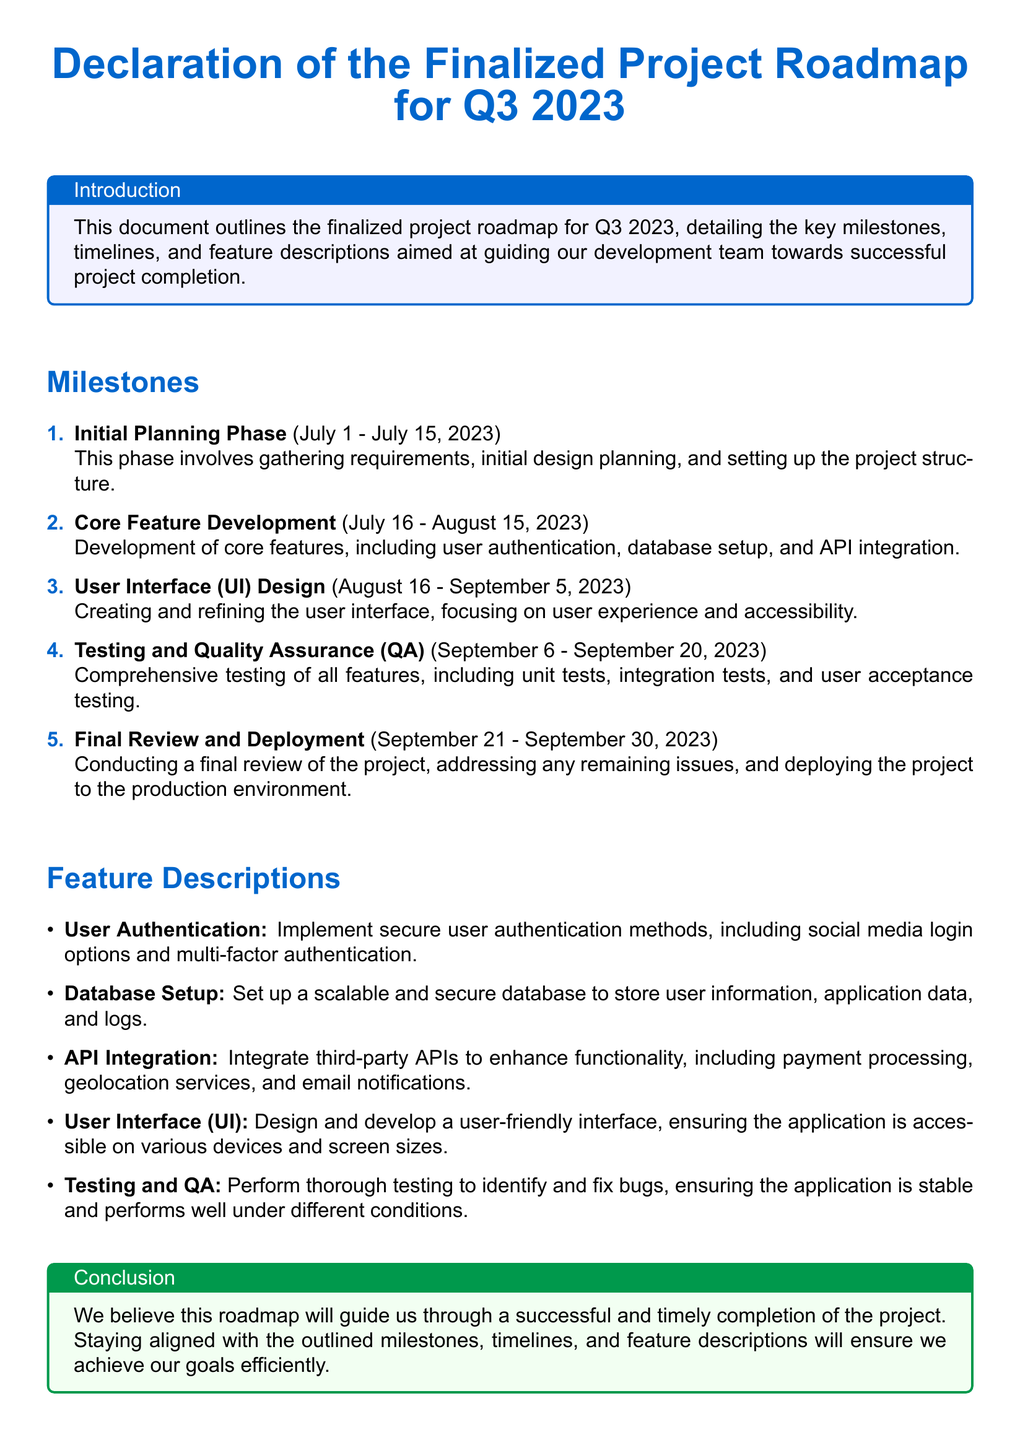What is the title of the document? The title is prominently displayed at the top of the document, indicating the main subject it addresses.
Answer: Declaration of the Finalized Project Roadmap for Q3 2023 What is the duration of the Core Feature Development phase? This phase has specific start and end dates outlined, showing its time frame within Q3 2023.
Answer: July 16 - August 15, 2023 How many milestones are listed in the document? The number of milestones can be counted from the enumeration provided under the Milestones section.
Answer: Five What feature involves secure user authentication? This feature is explicitly named and described in the feature descriptions section of the document.
Answer: User Authentication What is the start date of the Initial Planning Phase? This date is provided in the context of the milestone details for this phase in the document.
Answer: July 1, 2023 Which phase includes comprehensive testing? The phase that focuses on testing is clearly stated among the listed milestones in the document.
Answer: Testing and Quality Assurance What is the concluding phase of the roadmap? The final milestone listed describes this last step before project's completion.
Answer: Final Review and Deployment What color is used for the section titles? The colors specified for the titles are mentioned at the beginning of the document.
Answer: My blue 